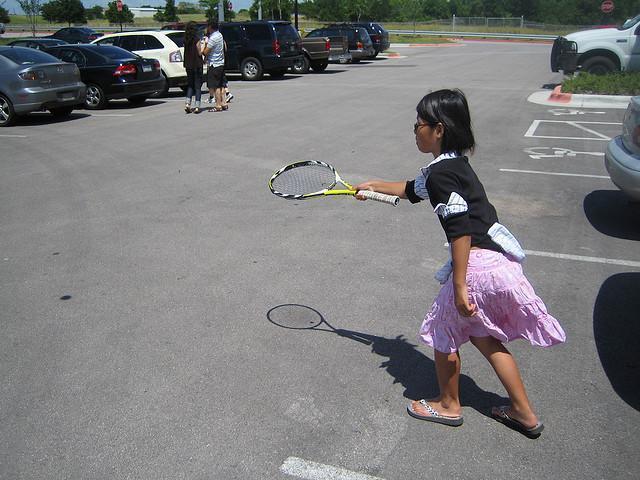How many cars are visible?
Give a very brief answer. 5. How many cows are in this picture?
Give a very brief answer. 0. 